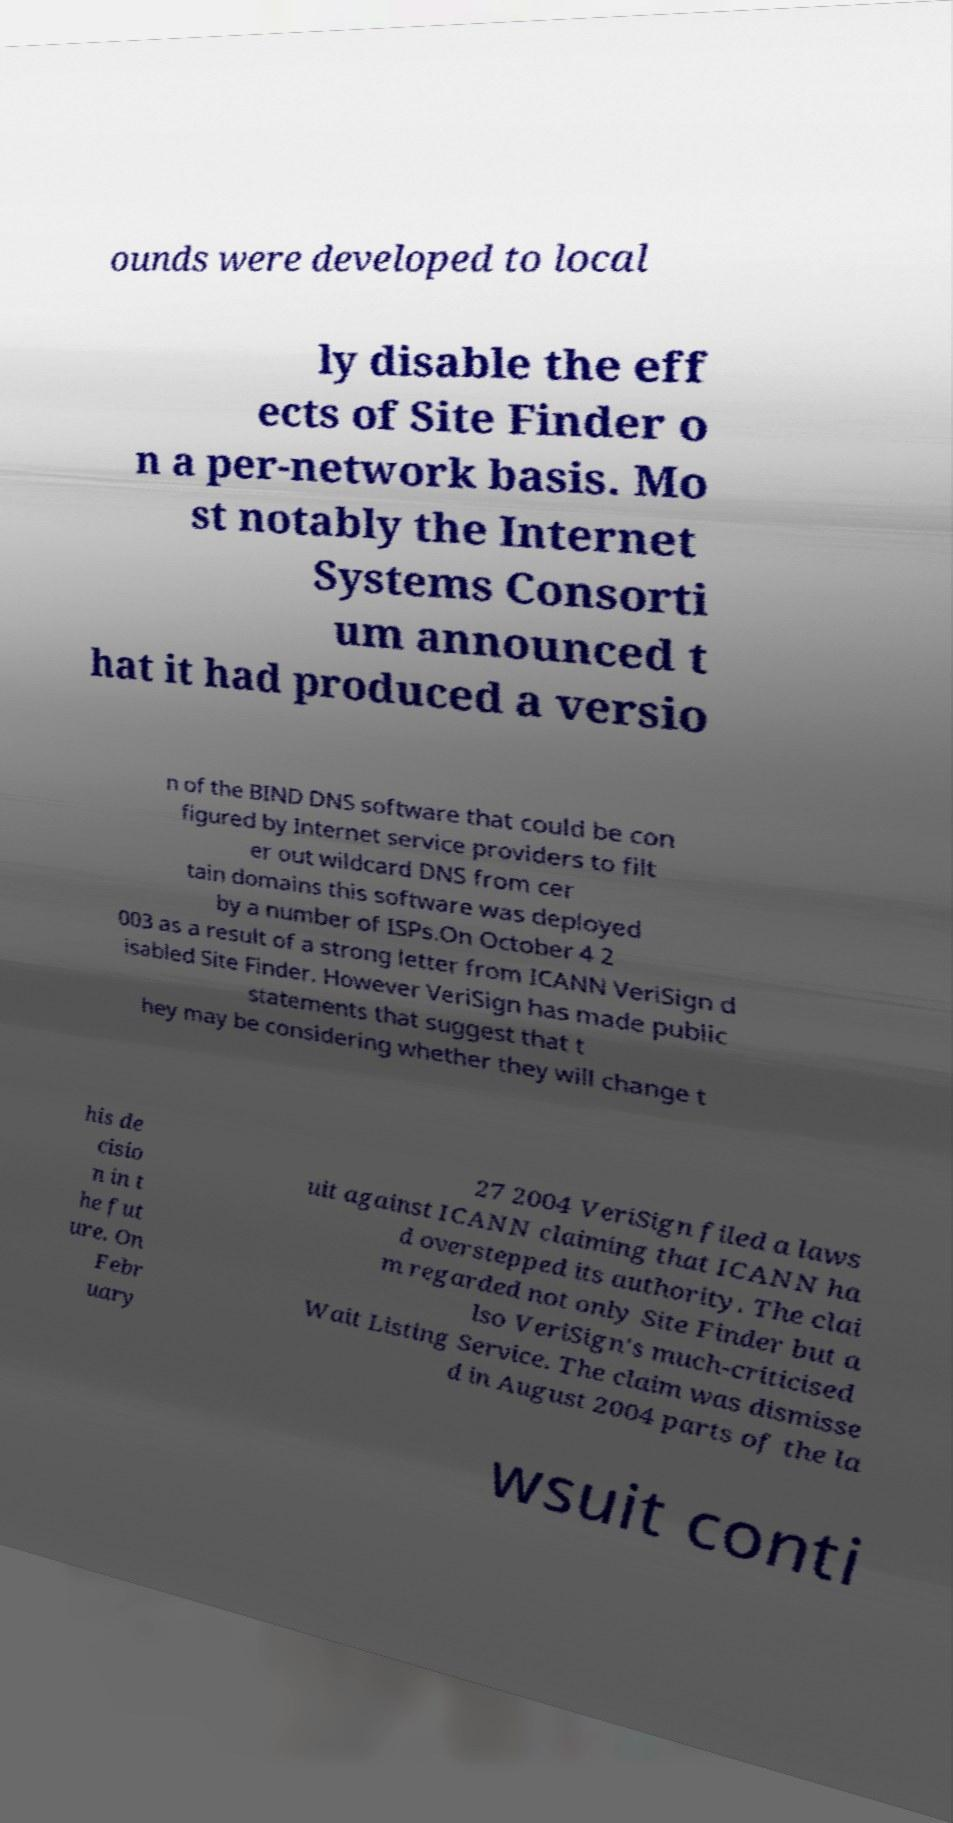Could you extract and type out the text from this image? ounds were developed to local ly disable the eff ects of Site Finder o n a per-network basis. Mo st notably the Internet Systems Consorti um announced t hat it had produced a versio n of the BIND DNS software that could be con figured by Internet service providers to filt er out wildcard DNS from cer tain domains this software was deployed by a number of ISPs.On October 4 2 003 as a result of a strong letter from ICANN VeriSign d isabled Site Finder. However VeriSign has made public statements that suggest that t hey may be considering whether they will change t his de cisio n in t he fut ure. On Febr uary 27 2004 VeriSign filed a laws uit against ICANN claiming that ICANN ha d overstepped its authority. The clai m regarded not only Site Finder but a lso VeriSign's much-criticised Wait Listing Service. The claim was dismisse d in August 2004 parts of the la wsuit conti 